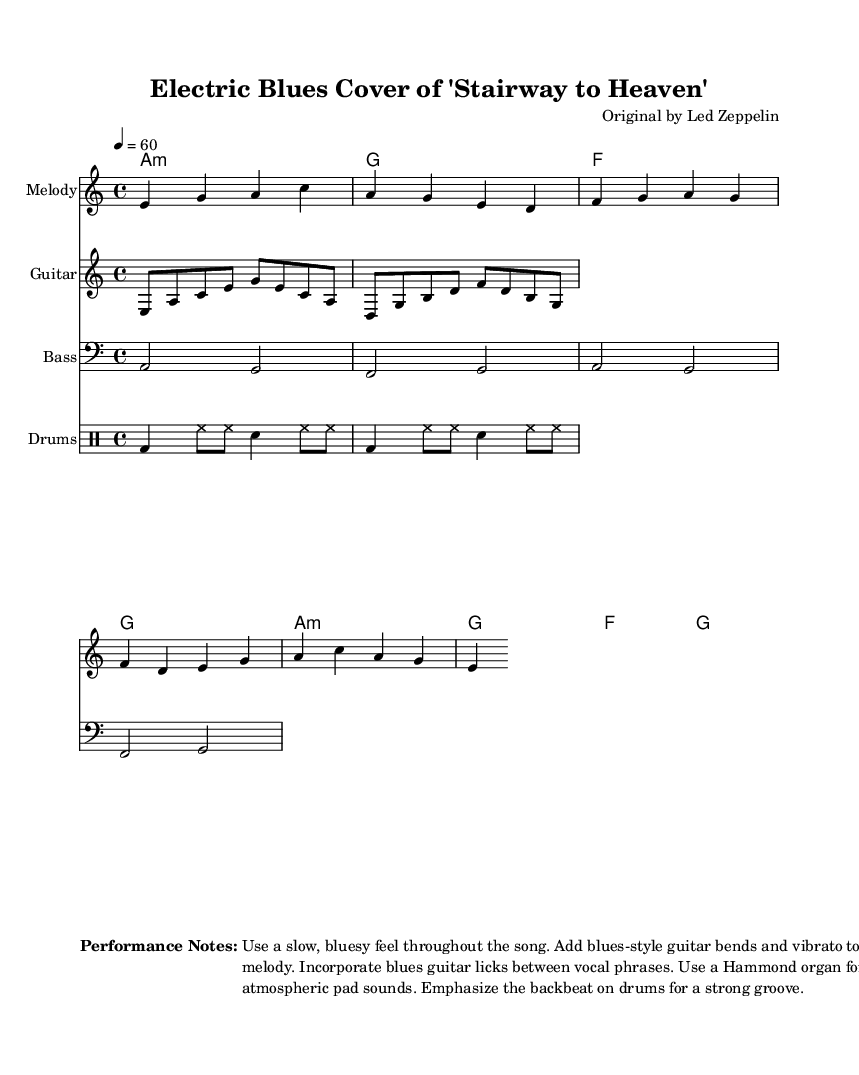What is the key signature of this music? The key signature is A minor, which has no sharps or flats. It is indicated by the key signature symbol at the beginning of the staff.
Answer: A minor What is the time signature of this piece? The time signature shown in the music is 4/4, which means there are four beats in a measure and the quarter note gets one beat. It can be identified at the beginning of the music score.
Answer: 4/4 What is the indicated tempo for this piece? The tempo indicated is 60 beats per minute, which is marked at the beginning of the score. This tells the performer to play at a slow pace suitable for blues music.
Answer: 60 How many measures are in the melody section? The melody section consists of two lines of music, each containing four measures, hence a total of eight measures can be counted.
Answer: 8 measures What is the primary chord used in this piece? The primary chord used in the music is A minor, which is indicated in the chord names section. The other chords provide harmonic support but A minor is the root.
Answer: A minor Which instrument is primarily highlighted in the arrangement? The guitar is primarily highlighted in the arrangement, as it features a dedicated staff for the guitar riff that stands out and adds a bluesy character to the arrangement.
Answer: Guitar What musical style does this piece represent? This piece represents the electric blues style, as indicated by the title and the performance notes suggesting a bluesy feel, guitar bends, and a strong groove from the drums.
Answer: Electric blues 